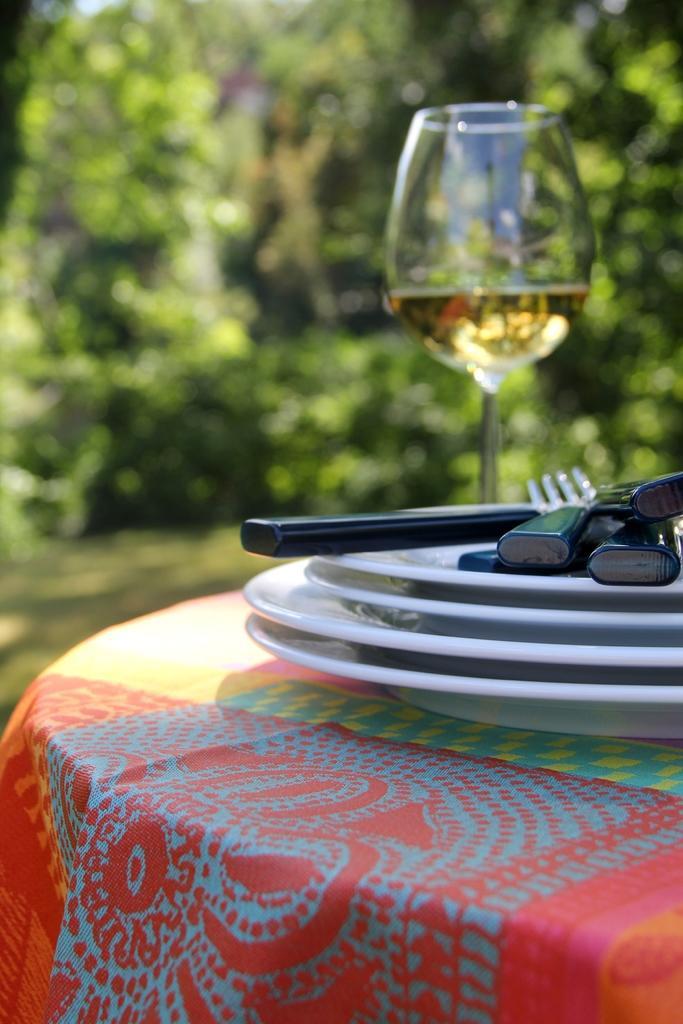Please provide a concise description of this image. In this image I see 4 plates, spoons and forks and a glass on a table. 